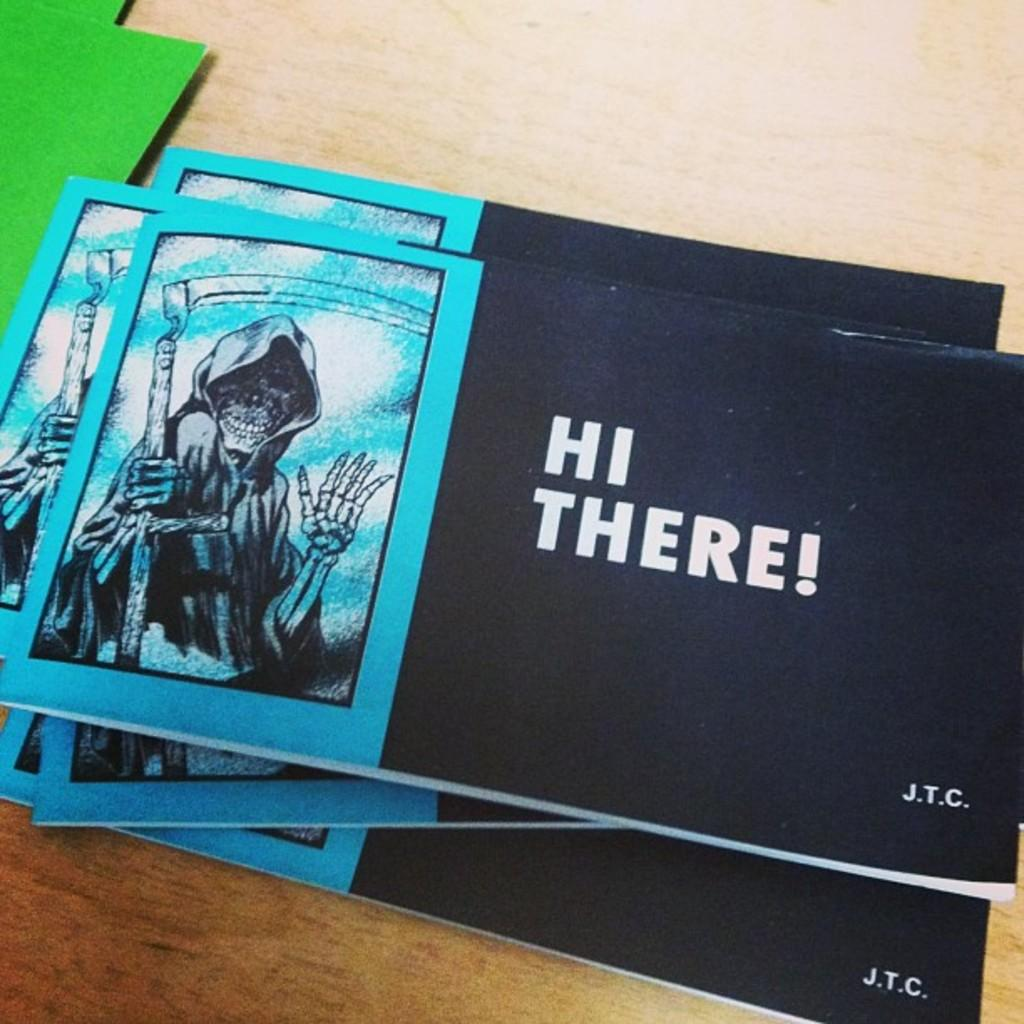<image>
Write a terse but informative summary of the picture. A stack of booklets that say "hi there!" are sitting on a table. 